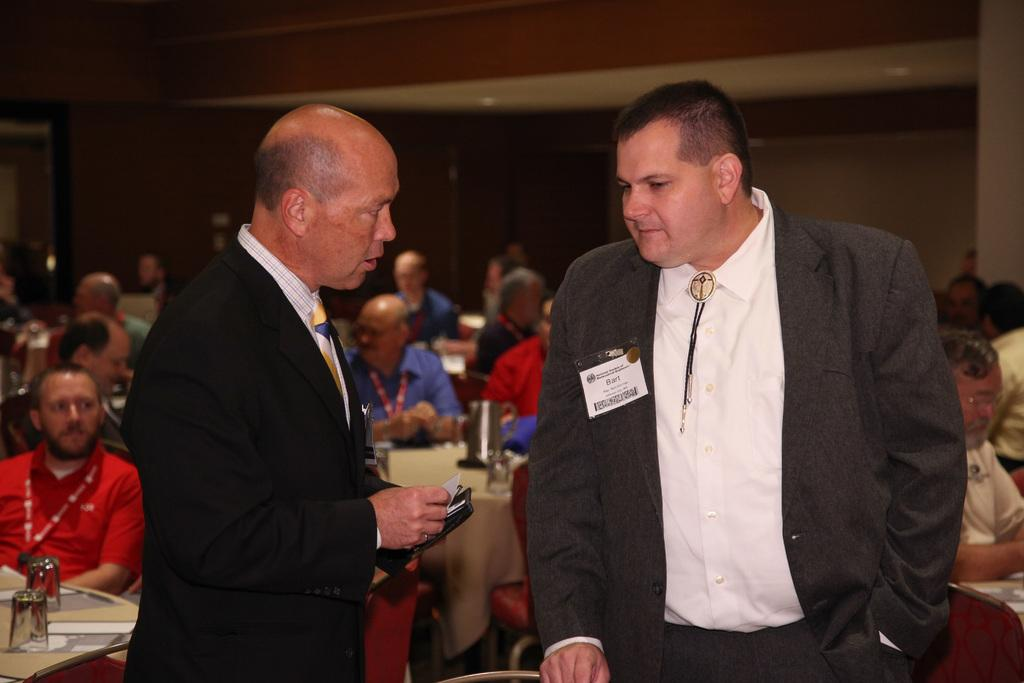What is the person in the image holding? The person in the image is holding a name card. How many people are in the image? There is a group of people in the image. What type of furniture is present in the image? There are tables in the image. What can be seen in the image that might be used for drinking? There are glasses in the image. What is a feature of the background in the image? There is a wall in the image. Can you describe any other objects in the image? There are some unspecified objects in the image. What type of mint is being served in the image? There is no mint present in the image. Can you describe the road in the image? There is no road present in the image. 